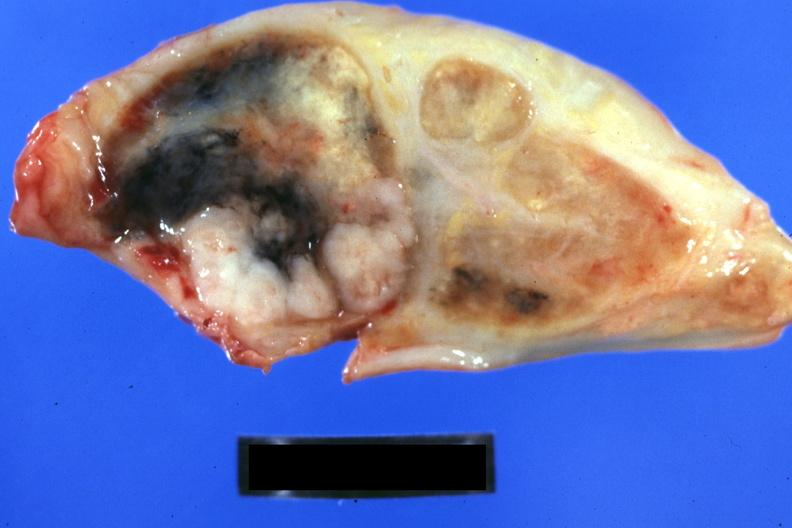what is present?
Answer the question using a single word or phrase. Lymph node 